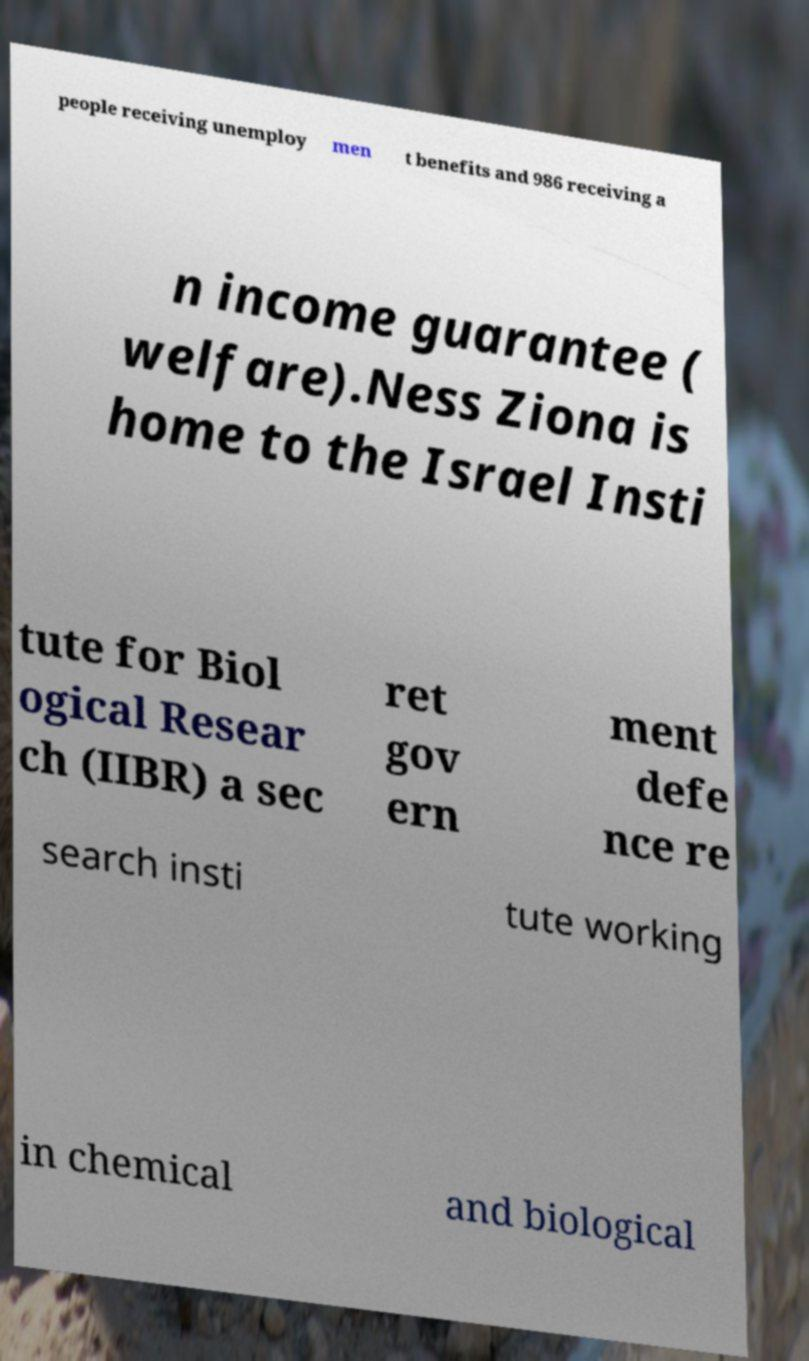Can you read and provide the text displayed in the image?This photo seems to have some interesting text. Can you extract and type it out for me? people receiving unemploy men t benefits and 986 receiving a n income guarantee ( welfare).Ness Ziona is home to the Israel Insti tute for Biol ogical Resear ch (IIBR) a sec ret gov ern ment defe nce re search insti tute working in chemical and biological 